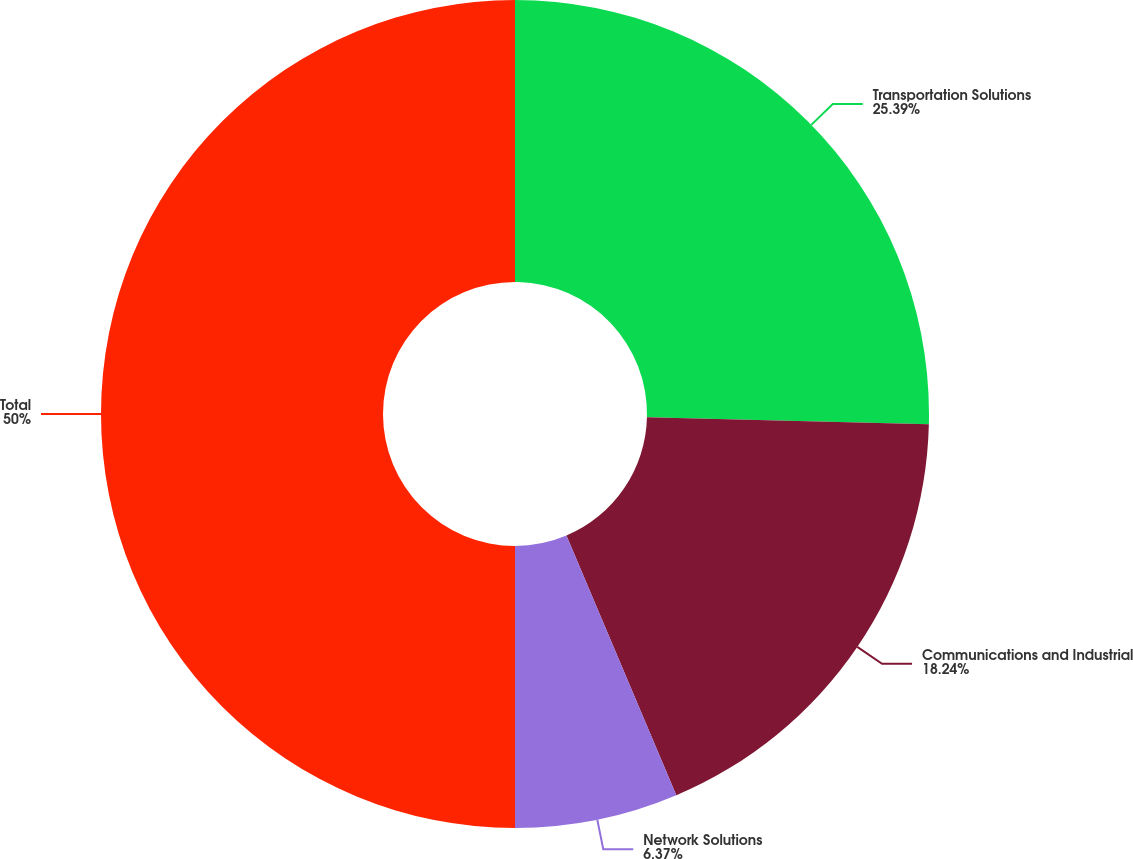<chart> <loc_0><loc_0><loc_500><loc_500><pie_chart><fcel>Transportation Solutions<fcel>Communications and Industrial<fcel>Network Solutions<fcel>Total<nl><fcel>25.39%<fcel>18.24%<fcel>6.37%<fcel>50.0%<nl></chart> 